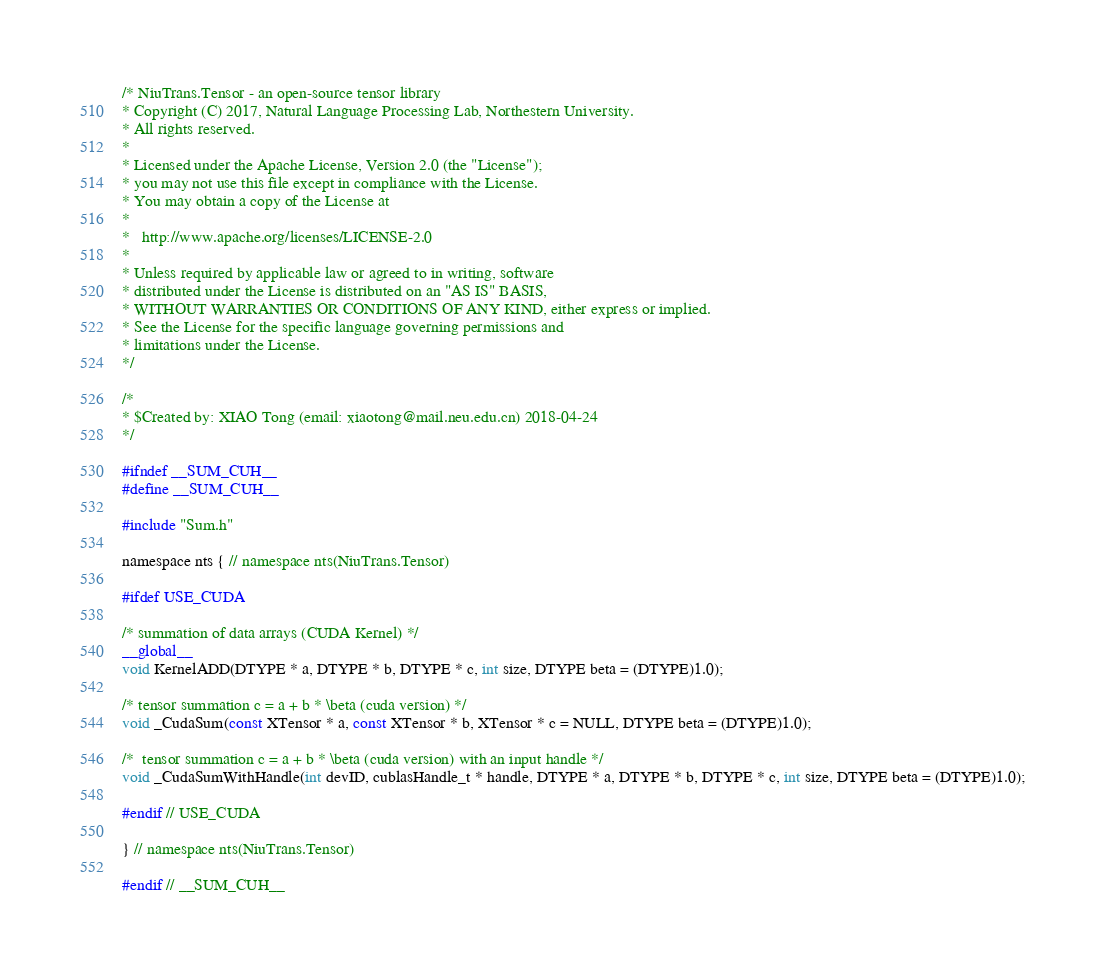<code> <loc_0><loc_0><loc_500><loc_500><_Cuda_>/* NiuTrans.Tensor - an open-source tensor library
* Copyright (C) 2017, Natural Language Processing Lab, Northestern University.
* All rights reserved.
*
* Licensed under the Apache License, Version 2.0 (the "License");
* you may not use this file except in compliance with the License.
* You may obtain a copy of the License at
*
*   http://www.apache.org/licenses/LICENSE-2.0
*
* Unless required by applicable law or agreed to in writing, software
* distributed under the License is distributed on an "AS IS" BASIS,
* WITHOUT WARRANTIES OR CONDITIONS OF ANY KIND, either express or implied.
* See the License for the specific language governing permissions and
* limitations under the License.
*/

/*
* $Created by: XIAO Tong (email: xiaotong@mail.neu.edu.cn) 2018-04-24
*/

#ifndef __SUM_CUH__
#define __SUM_CUH__

#include "Sum.h"

namespace nts { // namespace nts(NiuTrans.Tensor)

#ifdef USE_CUDA

/* summation of data arrays (CUDA Kernel) */
__global__
void KernelADD(DTYPE * a, DTYPE * b, DTYPE * c, int size, DTYPE beta = (DTYPE)1.0);

/* tensor summation c = a + b * \beta (cuda version) */
void _CudaSum(const XTensor * a, const XTensor * b, XTensor * c = NULL, DTYPE beta = (DTYPE)1.0);

/*  tensor summation c = a + b * \beta (cuda version) with an input handle */
void _CudaSumWithHandle(int devID, cublasHandle_t * handle, DTYPE * a, DTYPE * b, DTYPE * c, int size, DTYPE beta = (DTYPE)1.0);

#endif // USE_CUDA

} // namespace nts(NiuTrans.Tensor)

#endif // __SUM_CUH__
</code> 